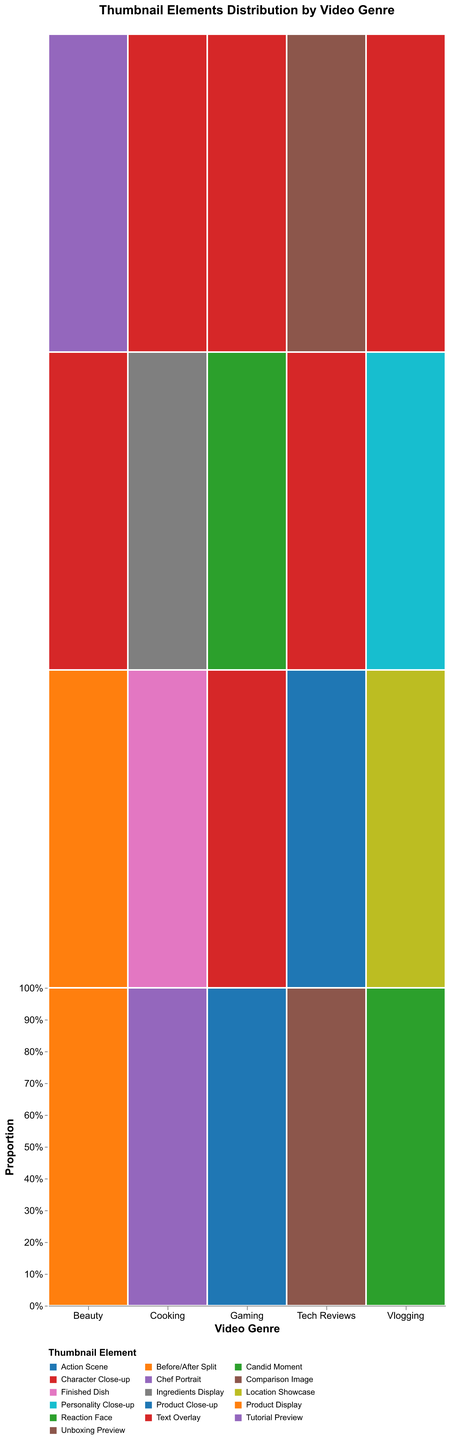What is the title of the figure? The figure's title is displayed at the top-center part of the plot.
Answer: Thumbnail Elements Distribution by Video Genre What are the X-axis and Y-axis labels in the figure? The X-axis is labeled "Video Genre" indicating different genres of videos, and the Y-axis is labeled "Proportion" indicating the proportion of each thumbnail element within a genre.
Answer: "Video Genre" and "Proportion" Which thumbnail element has the highest click-through rate in the Beauty genre? To find the thumbnail element with the highest click-through rate in the Beauty genre, look within the Beauty section of the plot and identify the element with the largest proportion. The "Before/After Split" has the largest area, indicating the highest click-through rate.
Answer: Before/After Split Which video genre has the most diverse set of thumbnail elements used? The most diverse set of thumbnail elements would be indicated by the genre with the most distinct sections (different colors) in the mosaic plot. By observing, Beauty and Tech Reviews both have a diverse range of elements.
Answer: Beauty and Tech Reviews What is the proportion of "Text Overlay" used in the Cooking genre compared to the total elements in the same genre? In the Cooking genre, locate the "Text Overlay" segment, and note its proportion of 0.07. Since the Y-axis in mosaic plots already depicts proportions, this value can be read directly.
Answer: 0.07 Which genre has the highest click-through rate for thumbnails featuring "Reaction Face"? Check the "Reaction Face" segments across all video genres. Gaming is the only genre that features "Reaction Face” with a click-through rate of 0.18.
Answer: Gaming In which genre does "Text Overlay" appear least frequently? Compare the size of the "Text Overlay" segments across all genres. The Cooking genre has the smallest segment for "Text Overlay," indicating it appears the least.
Answer: Cooking What is the combined proportion of the two highest click-through rate thumbnail elements in the Gaming genre? In the Gaming genre, "Reaction Face" and "Action Scene" have the click-through rates of 0.18 and 0.15 respectively. Their combined proportion is 0.18 + 0.15.
Answer: 0.33 